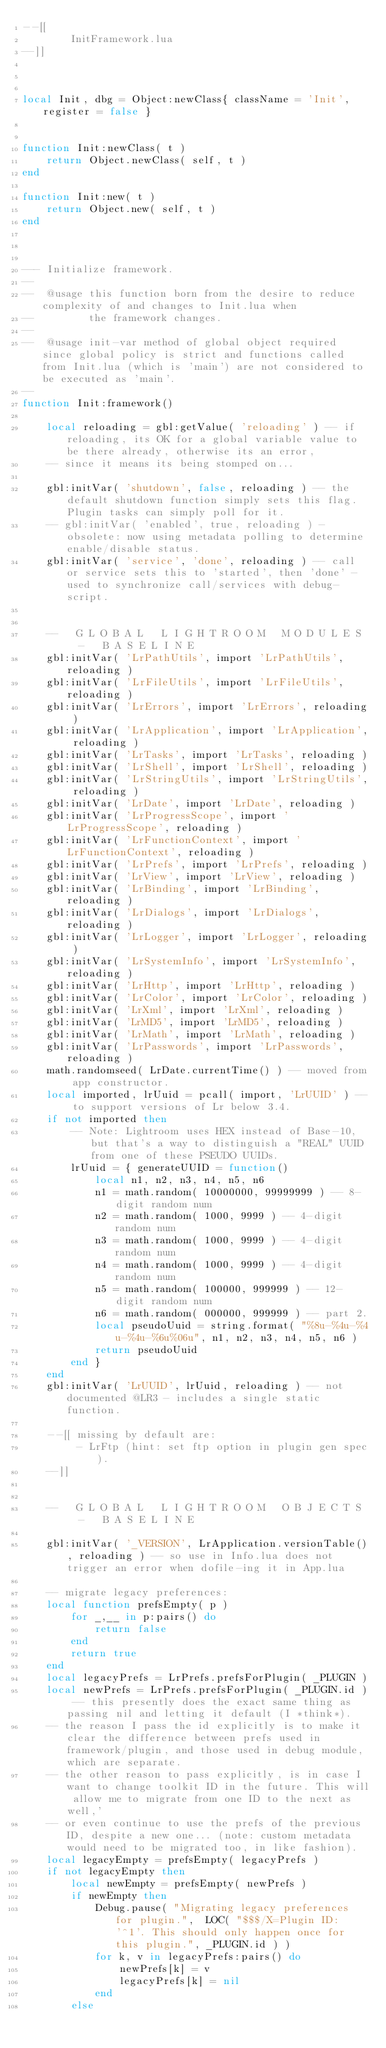<code> <loc_0><loc_0><loc_500><loc_500><_Lua_>--[[
        InitFramework.lua
--]]



local Init, dbg = Object:newClass{ className = 'Init', register = false }


function Init:newClass( t )
    return Object.newClass( self, t )
end

function Init:new( t )
    return Object.new( self, t )
end



--- Initialize framework.
--
--  @usage this function born from the desire to reduce complexity of and changes to Init.lua when
--         the framework changes.
--
--  @usage init-var method of global object required since global policy is strict and functions called from Init.lua (which is 'main') are not considered to be executed as 'main'.
--
function Init:framework()

    local reloading = gbl:getValue( 'reloading' ) -- if reloading, its OK for a global variable value to be there already, otherwise its an error,
    -- since it means its being stomped on...

    gbl:initVar( 'shutdown', false, reloading ) -- the default shutdown function simply sets this flag. Plugin tasks can simply poll for it.
    -- gbl:initVar( 'enabled', true, reloading ) - obsolete: now using metadata polling to determine enable/disable status.
    gbl:initVar( 'service', 'done', reloading ) -- call or service sets this to 'started', then 'done' - used to synchronize call/services with debug-script.
    
    
    --   G L O B A L   L I G H T R O O M   M O D U L E S   -   B A S E L I N E
    gbl:initVar( 'LrPathUtils', import 'LrPathUtils', reloading )
    gbl:initVar( 'LrFileUtils', import 'LrFileUtils', reloading ) 
    gbl:initVar( 'LrErrors', import 'LrErrors', reloading ) 
    gbl:initVar( 'LrApplication', import 'LrApplication', reloading )
    gbl:initVar( 'LrTasks', import 'LrTasks', reloading )
    gbl:initVar( 'LrShell', import 'LrShell', reloading )
    gbl:initVar( 'LrStringUtils', import 'LrStringUtils', reloading )
    gbl:initVar( 'LrDate', import 'LrDate', reloading )
    gbl:initVar( 'LrProgressScope', import 'LrProgressScope', reloading )
    gbl:initVar( 'LrFunctionContext', import 'LrFunctionContext', reloading )
    gbl:initVar( 'LrPrefs', import 'LrPrefs', reloading )
    gbl:initVar( 'LrView', import 'LrView', reloading )
    gbl:initVar( 'LrBinding', import 'LrBinding', reloading )
    gbl:initVar( 'LrDialogs', import 'LrDialogs', reloading )
    gbl:initVar( 'LrLogger', import 'LrLogger', reloading )
    gbl:initVar( 'LrSystemInfo', import 'LrSystemInfo', reloading )
    gbl:initVar( 'LrHttp', import 'LrHttp', reloading )
    gbl:initVar( 'LrColor', import 'LrColor', reloading )
    gbl:initVar( 'LrXml', import 'LrXml', reloading )
    gbl:initVar( 'LrMD5', import 'LrMD5', reloading )
    gbl:initVar( 'LrMath', import 'LrMath', reloading )
    gbl:initVar( 'LrPasswords', import 'LrPasswords', reloading )
    math.randomseed( LrDate.currentTime() ) -- moved from app constructor.
    local imported, lrUuid = pcall( import, 'LrUUID' ) -- to support versions of Lr below 3.4.
    if not imported then
        -- Note: Lightroom uses HEX instead of Base-10, but that's a way to distinguish a "REAL" UUID from one of these PSEUDO UUIDs.
        lrUuid = { generateUUID = function()
            local n1, n2, n3, n4, n5, n6
            n1 = math.random( 10000000, 99999999 ) -- 8-digit random num
            n2 = math.random( 1000, 9999 ) -- 4-digit random num
            n3 = math.random( 1000, 9999 ) -- 4-digit random num
            n4 = math.random( 1000, 9999 ) -- 4-digit random num
            n5 = math.random( 100000, 999999 ) -- 12-digit random num
            n6 = math.random( 000000, 999999 ) -- part 2.
            local pseudoUuid = string.format( "%8u-%4u-%4u-%4u-%6u%06u", n1, n2, n3, n4, n5, n6 )
            return pseudoUuid
        end }
    end
    gbl:initVar( 'LrUUID', lrUuid, reloading ) -- not documented @LR3 - includes a single static function.
    
    --[[ missing by default are:
         - LrFtp (hint: set ftp option in plugin gen spec).
    --]]


    --   G L O B A L   L I G H T R O O M   O B J E C T S   -   B A S E L I N E
    
    gbl:initVar( '_VERSION', LrApplication.versionTable(), reloading ) -- so use in Info.lua does not trigger an error when dofile-ing it in App.lua
    
    -- migrate legacy preferences:
    local function prefsEmpty( p )
        for _,__ in p:pairs() do
            return false
        end
        return true
    end
    local legacyPrefs = LrPrefs.prefsForPlugin( _PLUGIN )
    local newPrefs = LrPrefs.prefsForPlugin( _PLUGIN.id ) -- this presently does the exact same thing as passing nil and letting it default (I *think*).
    -- the reason I pass the id explicitly is to make it clear the difference between prefs used in framework/plugin, and those used in debug module, which are separate.
    -- the other reason to pass explicitly, is in case I want to change toolkit ID in the future. This will allow me to migrate from one ID to the next as well,'
    -- or even continue to use the prefs of the previous ID, despite a new one... (note: custom metadata would need to be migrated too, in like fashion).
    local legacyEmpty = prefsEmpty( legacyPrefs )
    if not legacyEmpty then
        local newEmpty = prefsEmpty( newPrefs )
        if newEmpty then
            Debug.pause( "Migrating legacy preferences for plugin.",  LOC( "$$$/X=Plugin ID: '^1'. This should only happen once for this plugin.", _PLUGIN.id ) )
            for k, v in legacyPrefs:pairs() do
                newPrefs[k] = v
                legacyPrefs[k] = nil
            end
        else</code> 